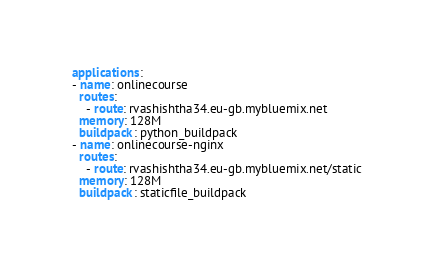Convert code to text. <code><loc_0><loc_0><loc_500><loc_500><_YAML_>  applications:
  - name: onlinecourse
    routes:
      - route: rvashishtha34.eu-gb.mybluemix.net
    memory: 128M
    buildpack: python_buildpack
  - name: onlinecourse-nginx
    routes:
      - route: rvashishtha34.eu-gb.mybluemix.net/static
    memory: 128M
    buildpack: staticfile_buildpack</code> 